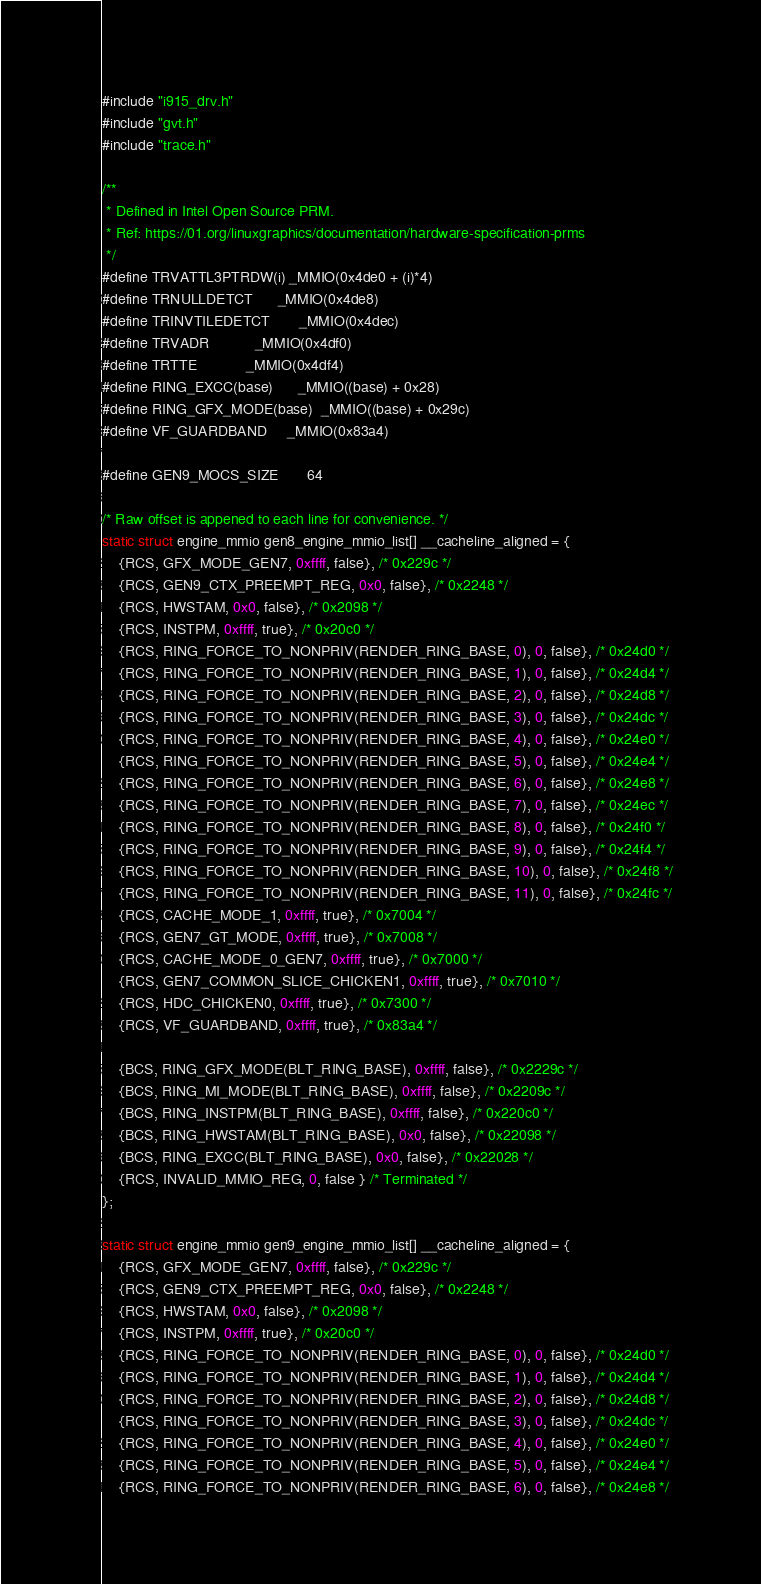<code> <loc_0><loc_0><loc_500><loc_500><_C_>#include "i915_drv.h"
#include "gvt.h"
#include "trace.h"

/**
 * Defined in Intel Open Source PRM.
 * Ref: https://01.org/linuxgraphics/documentation/hardware-specification-prms
 */
#define TRVATTL3PTRDW(i)	_MMIO(0x4de0 + (i)*4)
#define TRNULLDETCT		_MMIO(0x4de8)
#define TRINVTILEDETCT		_MMIO(0x4dec)
#define TRVADR			_MMIO(0x4df0)
#define TRTTE			_MMIO(0x4df4)
#define RING_EXCC(base)		_MMIO((base) + 0x28)
#define RING_GFX_MODE(base)	_MMIO((base) + 0x29c)
#define VF_GUARDBAND		_MMIO(0x83a4)

#define GEN9_MOCS_SIZE		64

/* Raw offset is appened to each line for convenience. */
static struct engine_mmio gen8_engine_mmio_list[] __cacheline_aligned = {
	{RCS, GFX_MODE_GEN7, 0xffff, false}, /* 0x229c */
	{RCS, GEN9_CTX_PREEMPT_REG, 0x0, false}, /* 0x2248 */
	{RCS, HWSTAM, 0x0, false}, /* 0x2098 */
	{RCS, INSTPM, 0xffff, true}, /* 0x20c0 */
	{RCS, RING_FORCE_TO_NONPRIV(RENDER_RING_BASE, 0), 0, false}, /* 0x24d0 */
	{RCS, RING_FORCE_TO_NONPRIV(RENDER_RING_BASE, 1), 0, false}, /* 0x24d4 */
	{RCS, RING_FORCE_TO_NONPRIV(RENDER_RING_BASE, 2), 0, false}, /* 0x24d8 */
	{RCS, RING_FORCE_TO_NONPRIV(RENDER_RING_BASE, 3), 0, false}, /* 0x24dc */
	{RCS, RING_FORCE_TO_NONPRIV(RENDER_RING_BASE, 4), 0, false}, /* 0x24e0 */
	{RCS, RING_FORCE_TO_NONPRIV(RENDER_RING_BASE, 5), 0, false}, /* 0x24e4 */
	{RCS, RING_FORCE_TO_NONPRIV(RENDER_RING_BASE, 6), 0, false}, /* 0x24e8 */
	{RCS, RING_FORCE_TO_NONPRIV(RENDER_RING_BASE, 7), 0, false}, /* 0x24ec */
	{RCS, RING_FORCE_TO_NONPRIV(RENDER_RING_BASE, 8), 0, false}, /* 0x24f0 */
	{RCS, RING_FORCE_TO_NONPRIV(RENDER_RING_BASE, 9), 0, false}, /* 0x24f4 */
	{RCS, RING_FORCE_TO_NONPRIV(RENDER_RING_BASE, 10), 0, false}, /* 0x24f8 */
	{RCS, RING_FORCE_TO_NONPRIV(RENDER_RING_BASE, 11), 0, false}, /* 0x24fc */
	{RCS, CACHE_MODE_1, 0xffff, true}, /* 0x7004 */
	{RCS, GEN7_GT_MODE, 0xffff, true}, /* 0x7008 */
	{RCS, CACHE_MODE_0_GEN7, 0xffff, true}, /* 0x7000 */
	{RCS, GEN7_COMMON_SLICE_CHICKEN1, 0xffff, true}, /* 0x7010 */
	{RCS, HDC_CHICKEN0, 0xffff, true}, /* 0x7300 */
	{RCS, VF_GUARDBAND, 0xffff, true}, /* 0x83a4 */

	{BCS, RING_GFX_MODE(BLT_RING_BASE), 0xffff, false}, /* 0x2229c */
	{BCS, RING_MI_MODE(BLT_RING_BASE), 0xffff, false}, /* 0x2209c */
	{BCS, RING_INSTPM(BLT_RING_BASE), 0xffff, false}, /* 0x220c0 */
	{BCS, RING_HWSTAM(BLT_RING_BASE), 0x0, false}, /* 0x22098 */
	{BCS, RING_EXCC(BLT_RING_BASE), 0x0, false}, /* 0x22028 */
	{RCS, INVALID_MMIO_REG, 0, false } /* Terminated */
};

static struct engine_mmio gen9_engine_mmio_list[] __cacheline_aligned = {
	{RCS, GFX_MODE_GEN7, 0xffff, false}, /* 0x229c */
	{RCS, GEN9_CTX_PREEMPT_REG, 0x0, false}, /* 0x2248 */
	{RCS, HWSTAM, 0x0, false}, /* 0x2098 */
	{RCS, INSTPM, 0xffff, true}, /* 0x20c0 */
	{RCS, RING_FORCE_TO_NONPRIV(RENDER_RING_BASE, 0), 0, false}, /* 0x24d0 */
	{RCS, RING_FORCE_TO_NONPRIV(RENDER_RING_BASE, 1), 0, false}, /* 0x24d4 */
	{RCS, RING_FORCE_TO_NONPRIV(RENDER_RING_BASE, 2), 0, false}, /* 0x24d8 */
	{RCS, RING_FORCE_TO_NONPRIV(RENDER_RING_BASE, 3), 0, false}, /* 0x24dc */
	{RCS, RING_FORCE_TO_NONPRIV(RENDER_RING_BASE, 4), 0, false}, /* 0x24e0 */
	{RCS, RING_FORCE_TO_NONPRIV(RENDER_RING_BASE, 5), 0, false}, /* 0x24e4 */
	{RCS, RING_FORCE_TO_NONPRIV(RENDER_RING_BASE, 6), 0, false}, /* 0x24e8 */</code> 